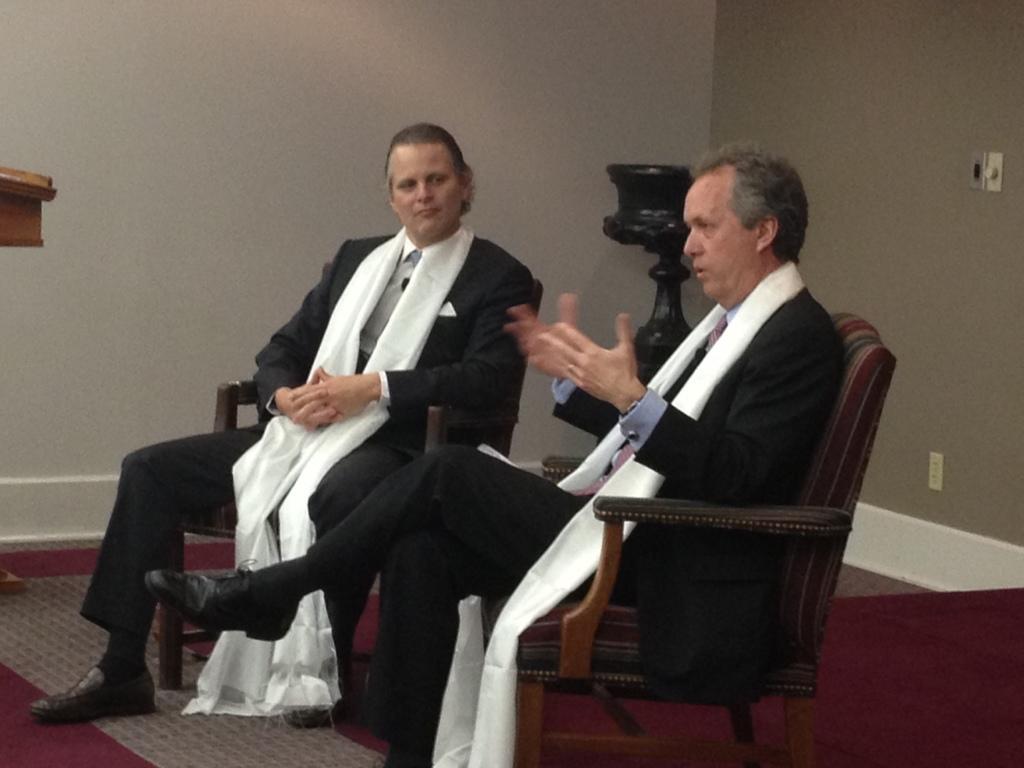Describe this image in one or two sentences. In this image I can see two people sitting on the chairs. These people are wearing the black and white color dresses. In the back I can see the black color object and the wall. 